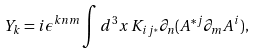Convert formula to latex. <formula><loc_0><loc_0><loc_500><loc_500>Y _ { k } = i \epsilon ^ { k n m } \int d ^ { 3 } x \, K _ { i j ^ { * } } \partial _ { n } ( A ^ { * j } \partial _ { m } A ^ { i } ) ,</formula> 